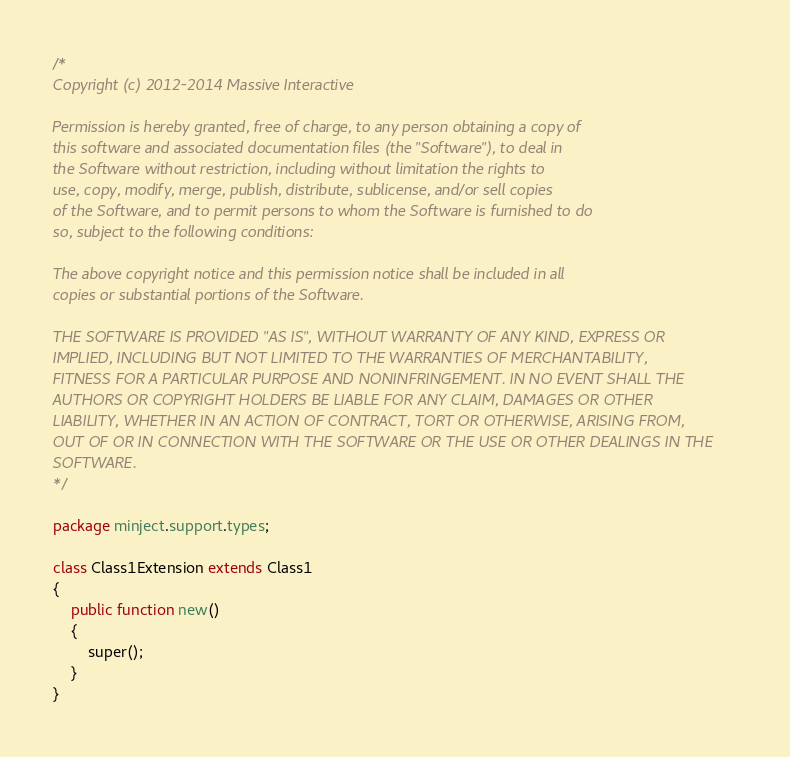<code> <loc_0><loc_0><loc_500><loc_500><_Haxe_>/*
Copyright (c) 2012-2014 Massive Interactive

Permission is hereby granted, free of charge, to any person obtaining a copy of 
this software and associated documentation files (the "Software"), to deal in 
the Software without restriction, including without limitation the rights to 
use, copy, modify, merge, publish, distribute, sublicense, and/or sell copies 
of the Software, and to permit persons to whom the Software is furnished to do 
so, subject to the following conditions:

The above copyright notice and this permission notice shall be included in all 
copies or substantial portions of the Software.

THE SOFTWARE IS PROVIDED "AS IS", WITHOUT WARRANTY OF ANY KIND, EXPRESS OR 
IMPLIED, INCLUDING BUT NOT LIMITED TO THE WARRANTIES OF MERCHANTABILITY, 
FITNESS FOR A PARTICULAR PURPOSE AND NONINFRINGEMENT. IN NO EVENT SHALL THE 
AUTHORS OR COPYRIGHT HOLDERS BE LIABLE FOR ANY CLAIM, DAMAGES OR OTHER 
LIABILITY, WHETHER IN AN ACTION OF CONTRACT, TORT OR OTHERWISE, ARISING FROM, 
OUT OF OR IN CONNECTION WITH THE SOFTWARE OR THE USE OR OTHER DEALINGS IN THE 
SOFTWARE.
*/

package minject.support.types;

class Class1Extension extends Class1
{
	public function new()
	{
		super();
	}
}
</code> 